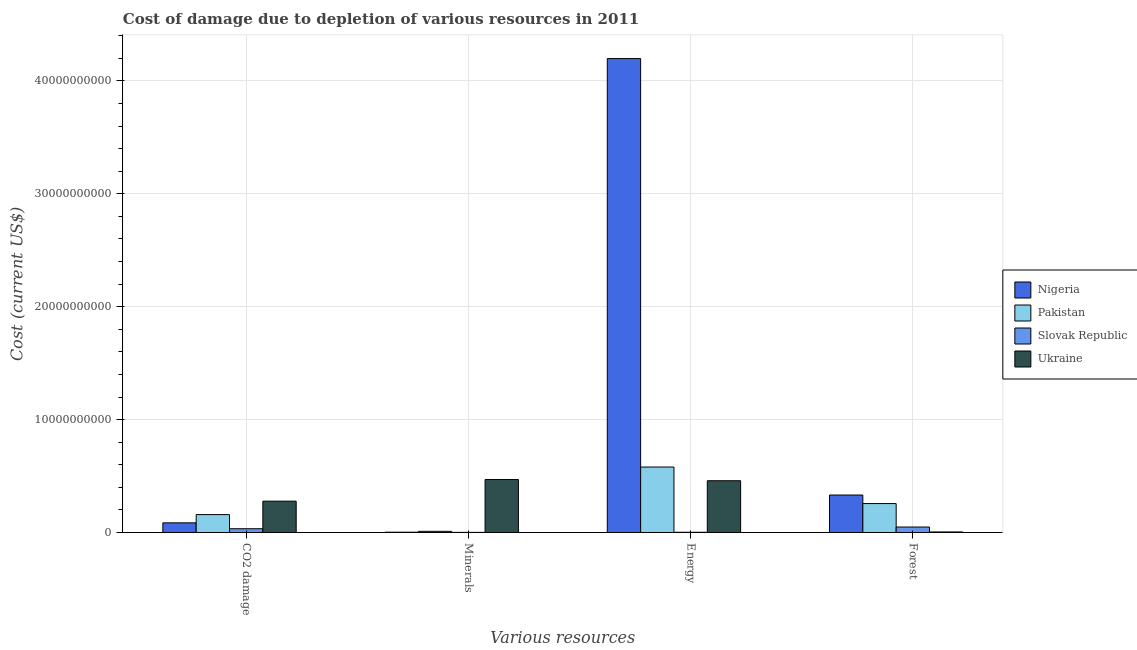How many different coloured bars are there?
Keep it short and to the point. 4. Are the number of bars per tick equal to the number of legend labels?
Make the answer very short. Yes. How many bars are there on the 3rd tick from the left?
Offer a very short reply. 4. How many bars are there on the 1st tick from the right?
Your response must be concise. 4. What is the label of the 4th group of bars from the left?
Your answer should be very brief. Forest. What is the cost of damage due to depletion of energy in Ukraine?
Make the answer very short. 4.58e+09. Across all countries, what is the maximum cost of damage due to depletion of energy?
Offer a terse response. 4.20e+1. Across all countries, what is the minimum cost of damage due to depletion of energy?
Keep it short and to the point. 1.89e+07. In which country was the cost of damage due to depletion of forests maximum?
Provide a short and direct response. Nigeria. In which country was the cost of damage due to depletion of energy minimum?
Provide a succinct answer. Slovak Republic. What is the total cost of damage due to depletion of energy in the graph?
Ensure brevity in your answer.  5.24e+1. What is the difference between the cost of damage due to depletion of forests in Ukraine and that in Slovak Republic?
Make the answer very short. -4.36e+08. What is the difference between the cost of damage due to depletion of coal in Slovak Republic and the cost of damage due to depletion of forests in Ukraine?
Keep it short and to the point. 2.85e+08. What is the average cost of damage due to depletion of minerals per country?
Make the answer very short. 1.21e+09. What is the difference between the cost of damage due to depletion of coal and cost of damage due to depletion of minerals in Ukraine?
Ensure brevity in your answer.  -1.92e+09. In how many countries, is the cost of damage due to depletion of forests greater than 4000000000 US$?
Give a very brief answer. 0. What is the ratio of the cost of damage due to depletion of energy in Ukraine to that in Nigeria?
Keep it short and to the point. 0.11. Is the cost of damage due to depletion of energy in Ukraine less than that in Nigeria?
Your answer should be very brief. Yes. What is the difference between the highest and the second highest cost of damage due to depletion of energy?
Ensure brevity in your answer.  3.62e+1. What is the difference between the highest and the lowest cost of damage due to depletion of minerals?
Offer a very short reply. 4.68e+09. In how many countries, is the cost of damage due to depletion of forests greater than the average cost of damage due to depletion of forests taken over all countries?
Offer a terse response. 2. Is it the case that in every country, the sum of the cost of damage due to depletion of energy and cost of damage due to depletion of coal is greater than the sum of cost of damage due to depletion of forests and cost of damage due to depletion of minerals?
Ensure brevity in your answer.  Yes. What does the 4th bar from the left in Minerals represents?
Your response must be concise. Ukraine. What does the 1st bar from the right in CO2 damage represents?
Make the answer very short. Ukraine. How many bars are there?
Offer a very short reply. 16. Are all the bars in the graph horizontal?
Your response must be concise. No. How many countries are there in the graph?
Provide a succinct answer. 4. What is the difference between two consecutive major ticks on the Y-axis?
Your answer should be compact. 1.00e+1. Does the graph contain grids?
Your response must be concise. Yes. What is the title of the graph?
Your answer should be very brief. Cost of damage due to depletion of various resources in 2011 . What is the label or title of the X-axis?
Keep it short and to the point. Various resources. What is the label or title of the Y-axis?
Ensure brevity in your answer.  Cost (current US$). What is the Cost (current US$) of Nigeria in CO2 damage?
Your answer should be compact. 8.53e+08. What is the Cost (current US$) in Pakistan in CO2 damage?
Make the answer very short. 1.58e+09. What is the Cost (current US$) in Slovak Republic in CO2 damage?
Provide a succinct answer. 3.33e+08. What is the Cost (current US$) of Ukraine in CO2 damage?
Make the answer very short. 2.77e+09. What is the Cost (current US$) in Nigeria in Minerals?
Your answer should be very brief. 2.54e+07. What is the Cost (current US$) of Pakistan in Minerals?
Offer a very short reply. 1.02e+08. What is the Cost (current US$) of Slovak Republic in Minerals?
Your response must be concise. 8.71e+06. What is the Cost (current US$) in Ukraine in Minerals?
Make the answer very short. 4.69e+09. What is the Cost (current US$) in Nigeria in Energy?
Your answer should be very brief. 4.20e+1. What is the Cost (current US$) of Pakistan in Energy?
Give a very brief answer. 5.80e+09. What is the Cost (current US$) of Slovak Republic in Energy?
Provide a succinct answer. 1.89e+07. What is the Cost (current US$) in Ukraine in Energy?
Ensure brevity in your answer.  4.58e+09. What is the Cost (current US$) of Nigeria in Forest?
Offer a terse response. 3.32e+09. What is the Cost (current US$) of Pakistan in Forest?
Offer a very short reply. 2.56e+09. What is the Cost (current US$) in Slovak Republic in Forest?
Your answer should be compact. 4.84e+08. What is the Cost (current US$) in Ukraine in Forest?
Offer a terse response. 4.83e+07. Across all Various resources, what is the maximum Cost (current US$) of Nigeria?
Provide a succinct answer. 4.20e+1. Across all Various resources, what is the maximum Cost (current US$) of Pakistan?
Give a very brief answer. 5.80e+09. Across all Various resources, what is the maximum Cost (current US$) in Slovak Republic?
Make the answer very short. 4.84e+08. Across all Various resources, what is the maximum Cost (current US$) of Ukraine?
Provide a short and direct response. 4.69e+09. Across all Various resources, what is the minimum Cost (current US$) in Nigeria?
Make the answer very short. 2.54e+07. Across all Various resources, what is the minimum Cost (current US$) of Pakistan?
Make the answer very short. 1.02e+08. Across all Various resources, what is the minimum Cost (current US$) of Slovak Republic?
Your answer should be compact. 8.71e+06. Across all Various resources, what is the minimum Cost (current US$) of Ukraine?
Give a very brief answer. 4.83e+07. What is the total Cost (current US$) of Nigeria in the graph?
Your answer should be compact. 4.62e+1. What is the total Cost (current US$) in Pakistan in the graph?
Give a very brief answer. 1.00e+1. What is the total Cost (current US$) of Slovak Republic in the graph?
Make the answer very short. 8.45e+08. What is the total Cost (current US$) of Ukraine in the graph?
Offer a terse response. 1.21e+1. What is the difference between the Cost (current US$) of Nigeria in CO2 damage and that in Minerals?
Provide a succinct answer. 8.28e+08. What is the difference between the Cost (current US$) of Pakistan in CO2 damage and that in Minerals?
Make the answer very short. 1.48e+09. What is the difference between the Cost (current US$) of Slovak Republic in CO2 damage and that in Minerals?
Ensure brevity in your answer.  3.24e+08. What is the difference between the Cost (current US$) in Ukraine in CO2 damage and that in Minerals?
Make the answer very short. -1.92e+09. What is the difference between the Cost (current US$) in Nigeria in CO2 damage and that in Energy?
Provide a short and direct response. -4.11e+1. What is the difference between the Cost (current US$) in Pakistan in CO2 damage and that in Energy?
Offer a terse response. -4.21e+09. What is the difference between the Cost (current US$) in Slovak Republic in CO2 damage and that in Energy?
Provide a succinct answer. 3.14e+08. What is the difference between the Cost (current US$) of Ukraine in CO2 damage and that in Energy?
Make the answer very short. -1.81e+09. What is the difference between the Cost (current US$) in Nigeria in CO2 damage and that in Forest?
Offer a very short reply. -2.47e+09. What is the difference between the Cost (current US$) in Pakistan in CO2 damage and that in Forest?
Give a very brief answer. -9.77e+08. What is the difference between the Cost (current US$) in Slovak Republic in CO2 damage and that in Forest?
Offer a very short reply. -1.51e+08. What is the difference between the Cost (current US$) of Ukraine in CO2 damage and that in Forest?
Give a very brief answer. 2.73e+09. What is the difference between the Cost (current US$) of Nigeria in Minerals and that in Energy?
Keep it short and to the point. -4.20e+1. What is the difference between the Cost (current US$) of Pakistan in Minerals and that in Energy?
Provide a succinct answer. -5.70e+09. What is the difference between the Cost (current US$) of Slovak Republic in Minerals and that in Energy?
Offer a terse response. -1.02e+07. What is the difference between the Cost (current US$) in Ukraine in Minerals and that in Energy?
Keep it short and to the point. 1.05e+08. What is the difference between the Cost (current US$) in Nigeria in Minerals and that in Forest?
Your answer should be compact. -3.29e+09. What is the difference between the Cost (current US$) in Pakistan in Minerals and that in Forest?
Provide a short and direct response. -2.46e+09. What is the difference between the Cost (current US$) of Slovak Republic in Minerals and that in Forest?
Offer a terse response. -4.76e+08. What is the difference between the Cost (current US$) of Ukraine in Minerals and that in Forest?
Keep it short and to the point. 4.64e+09. What is the difference between the Cost (current US$) of Nigeria in Energy and that in Forest?
Offer a terse response. 3.87e+1. What is the difference between the Cost (current US$) in Pakistan in Energy and that in Forest?
Keep it short and to the point. 3.24e+09. What is the difference between the Cost (current US$) of Slovak Republic in Energy and that in Forest?
Offer a terse response. -4.65e+08. What is the difference between the Cost (current US$) of Ukraine in Energy and that in Forest?
Make the answer very short. 4.54e+09. What is the difference between the Cost (current US$) in Nigeria in CO2 damage and the Cost (current US$) in Pakistan in Minerals?
Provide a succinct answer. 7.51e+08. What is the difference between the Cost (current US$) of Nigeria in CO2 damage and the Cost (current US$) of Slovak Republic in Minerals?
Give a very brief answer. 8.45e+08. What is the difference between the Cost (current US$) of Nigeria in CO2 damage and the Cost (current US$) of Ukraine in Minerals?
Give a very brief answer. -3.84e+09. What is the difference between the Cost (current US$) in Pakistan in CO2 damage and the Cost (current US$) in Slovak Republic in Minerals?
Offer a terse response. 1.58e+09. What is the difference between the Cost (current US$) of Pakistan in CO2 damage and the Cost (current US$) of Ukraine in Minerals?
Your response must be concise. -3.11e+09. What is the difference between the Cost (current US$) of Slovak Republic in CO2 damage and the Cost (current US$) of Ukraine in Minerals?
Provide a short and direct response. -4.36e+09. What is the difference between the Cost (current US$) in Nigeria in CO2 damage and the Cost (current US$) in Pakistan in Energy?
Your answer should be compact. -4.94e+09. What is the difference between the Cost (current US$) of Nigeria in CO2 damage and the Cost (current US$) of Slovak Republic in Energy?
Offer a terse response. 8.34e+08. What is the difference between the Cost (current US$) in Nigeria in CO2 damage and the Cost (current US$) in Ukraine in Energy?
Offer a very short reply. -3.73e+09. What is the difference between the Cost (current US$) of Pakistan in CO2 damage and the Cost (current US$) of Slovak Republic in Energy?
Offer a terse response. 1.57e+09. What is the difference between the Cost (current US$) in Pakistan in CO2 damage and the Cost (current US$) in Ukraine in Energy?
Provide a succinct answer. -3.00e+09. What is the difference between the Cost (current US$) of Slovak Republic in CO2 damage and the Cost (current US$) of Ukraine in Energy?
Your answer should be very brief. -4.25e+09. What is the difference between the Cost (current US$) in Nigeria in CO2 damage and the Cost (current US$) in Pakistan in Forest?
Offer a terse response. -1.71e+09. What is the difference between the Cost (current US$) of Nigeria in CO2 damage and the Cost (current US$) of Slovak Republic in Forest?
Make the answer very short. 3.69e+08. What is the difference between the Cost (current US$) in Nigeria in CO2 damage and the Cost (current US$) in Ukraine in Forest?
Ensure brevity in your answer.  8.05e+08. What is the difference between the Cost (current US$) of Pakistan in CO2 damage and the Cost (current US$) of Slovak Republic in Forest?
Keep it short and to the point. 1.10e+09. What is the difference between the Cost (current US$) in Pakistan in CO2 damage and the Cost (current US$) in Ukraine in Forest?
Make the answer very short. 1.54e+09. What is the difference between the Cost (current US$) of Slovak Republic in CO2 damage and the Cost (current US$) of Ukraine in Forest?
Provide a succinct answer. 2.85e+08. What is the difference between the Cost (current US$) in Nigeria in Minerals and the Cost (current US$) in Pakistan in Energy?
Keep it short and to the point. -5.77e+09. What is the difference between the Cost (current US$) of Nigeria in Minerals and the Cost (current US$) of Slovak Republic in Energy?
Keep it short and to the point. 6.54e+06. What is the difference between the Cost (current US$) of Nigeria in Minerals and the Cost (current US$) of Ukraine in Energy?
Give a very brief answer. -4.56e+09. What is the difference between the Cost (current US$) in Pakistan in Minerals and the Cost (current US$) in Slovak Republic in Energy?
Provide a succinct answer. 8.35e+07. What is the difference between the Cost (current US$) of Pakistan in Minerals and the Cost (current US$) of Ukraine in Energy?
Your answer should be very brief. -4.48e+09. What is the difference between the Cost (current US$) in Slovak Republic in Minerals and the Cost (current US$) in Ukraine in Energy?
Offer a terse response. -4.58e+09. What is the difference between the Cost (current US$) in Nigeria in Minerals and the Cost (current US$) in Pakistan in Forest?
Provide a succinct answer. -2.54e+09. What is the difference between the Cost (current US$) in Nigeria in Minerals and the Cost (current US$) in Slovak Republic in Forest?
Your answer should be compact. -4.59e+08. What is the difference between the Cost (current US$) of Nigeria in Minerals and the Cost (current US$) of Ukraine in Forest?
Your answer should be very brief. -2.28e+07. What is the difference between the Cost (current US$) in Pakistan in Minerals and the Cost (current US$) in Slovak Republic in Forest?
Ensure brevity in your answer.  -3.82e+08. What is the difference between the Cost (current US$) in Pakistan in Minerals and the Cost (current US$) in Ukraine in Forest?
Provide a short and direct response. 5.41e+07. What is the difference between the Cost (current US$) of Slovak Republic in Minerals and the Cost (current US$) of Ukraine in Forest?
Offer a very short reply. -3.96e+07. What is the difference between the Cost (current US$) in Nigeria in Energy and the Cost (current US$) in Pakistan in Forest?
Make the answer very short. 3.94e+1. What is the difference between the Cost (current US$) of Nigeria in Energy and the Cost (current US$) of Slovak Republic in Forest?
Keep it short and to the point. 4.15e+1. What is the difference between the Cost (current US$) of Nigeria in Energy and the Cost (current US$) of Ukraine in Forest?
Make the answer very short. 4.19e+1. What is the difference between the Cost (current US$) of Pakistan in Energy and the Cost (current US$) of Slovak Republic in Forest?
Give a very brief answer. 5.31e+09. What is the difference between the Cost (current US$) in Pakistan in Energy and the Cost (current US$) in Ukraine in Forest?
Your answer should be very brief. 5.75e+09. What is the difference between the Cost (current US$) in Slovak Republic in Energy and the Cost (current US$) in Ukraine in Forest?
Ensure brevity in your answer.  -2.94e+07. What is the average Cost (current US$) of Nigeria per Various resources?
Offer a very short reply. 1.15e+1. What is the average Cost (current US$) of Pakistan per Various resources?
Give a very brief answer. 2.51e+09. What is the average Cost (current US$) of Slovak Republic per Various resources?
Offer a terse response. 2.11e+08. What is the average Cost (current US$) of Ukraine per Various resources?
Offer a very short reply. 3.02e+09. What is the difference between the Cost (current US$) of Nigeria and Cost (current US$) of Pakistan in CO2 damage?
Offer a very short reply. -7.31e+08. What is the difference between the Cost (current US$) of Nigeria and Cost (current US$) of Slovak Republic in CO2 damage?
Offer a very short reply. 5.20e+08. What is the difference between the Cost (current US$) in Nigeria and Cost (current US$) in Ukraine in CO2 damage?
Provide a short and direct response. -1.92e+09. What is the difference between the Cost (current US$) in Pakistan and Cost (current US$) in Slovak Republic in CO2 damage?
Give a very brief answer. 1.25e+09. What is the difference between the Cost (current US$) in Pakistan and Cost (current US$) in Ukraine in CO2 damage?
Your response must be concise. -1.19e+09. What is the difference between the Cost (current US$) of Slovak Republic and Cost (current US$) of Ukraine in CO2 damage?
Your answer should be very brief. -2.44e+09. What is the difference between the Cost (current US$) of Nigeria and Cost (current US$) of Pakistan in Minerals?
Your answer should be compact. -7.70e+07. What is the difference between the Cost (current US$) of Nigeria and Cost (current US$) of Slovak Republic in Minerals?
Provide a succinct answer. 1.67e+07. What is the difference between the Cost (current US$) of Nigeria and Cost (current US$) of Ukraine in Minerals?
Give a very brief answer. -4.66e+09. What is the difference between the Cost (current US$) of Pakistan and Cost (current US$) of Slovak Republic in Minerals?
Give a very brief answer. 9.37e+07. What is the difference between the Cost (current US$) in Pakistan and Cost (current US$) in Ukraine in Minerals?
Offer a very short reply. -4.59e+09. What is the difference between the Cost (current US$) of Slovak Republic and Cost (current US$) of Ukraine in Minerals?
Your answer should be compact. -4.68e+09. What is the difference between the Cost (current US$) of Nigeria and Cost (current US$) of Pakistan in Energy?
Offer a terse response. 3.62e+1. What is the difference between the Cost (current US$) in Nigeria and Cost (current US$) in Slovak Republic in Energy?
Your response must be concise. 4.20e+1. What is the difference between the Cost (current US$) of Nigeria and Cost (current US$) of Ukraine in Energy?
Offer a terse response. 3.74e+1. What is the difference between the Cost (current US$) in Pakistan and Cost (current US$) in Slovak Republic in Energy?
Ensure brevity in your answer.  5.78e+09. What is the difference between the Cost (current US$) in Pakistan and Cost (current US$) in Ukraine in Energy?
Ensure brevity in your answer.  1.21e+09. What is the difference between the Cost (current US$) of Slovak Republic and Cost (current US$) of Ukraine in Energy?
Ensure brevity in your answer.  -4.57e+09. What is the difference between the Cost (current US$) of Nigeria and Cost (current US$) of Pakistan in Forest?
Ensure brevity in your answer.  7.57e+08. What is the difference between the Cost (current US$) of Nigeria and Cost (current US$) of Slovak Republic in Forest?
Your answer should be compact. 2.83e+09. What is the difference between the Cost (current US$) in Nigeria and Cost (current US$) in Ukraine in Forest?
Your answer should be compact. 3.27e+09. What is the difference between the Cost (current US$) in Pakistan and Cost (current US$) in Slovak Republic in Forest?
Your answer should be compact. 2.08e+09. What is the difference between the Cost (current US$) in Pakistan and Cost (current US$) in Ukraine in Forest?
Make the answer very short. 2.51e+09. What is the difference between the Cost (current US$) in Slovak Republic and Cost (current US$) in Ukraine in Forest?
Offer a terse response. 4.36e+08. What is the ratio of the Cost (current US$) of Nigeria in CO2 damage to that in Minerals?
Make the answer very short. 33.55. What is the ratio of the Cost (current US$) in Pakistan in CO2 damage to that in Minerals?
Provide a short and direct response. 15.47. What is the ratio of the Cost (current US$) of Slovak Republic in CO2 damage to that in Minerals?
Provide a succinct answer. 38.27. What is the ratio of the Cost (current US$) of Ukraine in CO2 damage to that in Minerals?
Give a very brief answer. 0.59. What is the ratio of the Cost (current US$) of Nigeria in CO2 damage to that in Energy?
Make the answer very short. 0.02. What is the ratio of the Cost (current US$) of Pakistan in CO2 damage to that in Energy?
Keep it short and to the point. 0.27. What is the ratio of the Cost (current US$) of Slovak Republic in CO2 damage to that in Energy?
Provide a short and direct response. 17.64. What is the ratio of the Cost (current US$) in Ukraine in CO2 damage to that in Energy?
Offer a very short reply. 0.61. What is the ratio of the Cost (current US$) in Nigeria in CO2 damage to that in Forest?
Ensure brevity in your answer.  0.26. What is the ratio of the Cost (current US$) of Pakistan in CO2 damage to that in Forest?
Give a very brief answer. 0.62. What is the ratio of the Cost (current US$) of Slovak Republic in CO2 damage to that in Forest?
Keep it short and to the point. 0.69. What is the ratio of the Cost (current US$) of Ukraine in CO2 damage to that in Forest?
Provide a succinct answer. 57.47. What is the ratio of the Cost (current US$) of Nigeria in Minerals to that in Energy?
Keep it short and to the point. 0. What is the ratio of the Cost (current US$) in Pakistan in Minerals to that in Energy?
Provide a short and direct response. 0.02. What is the ratio of the Cost (current US$) of Slovak Republic in Minerals to that in Energy?
Ensure brevity in your answer.  0.46. What is the ratio of the Cost (current US$) of Nigeria in Minerals to that in Forest?
Make the answer very short. 0.01. What is the ratio of the Cost (current US$) in Pakistan in Minerals to that in Forest?
Keep it short and to the point. 0.04. What is the ratio of the Cost (current US$) of Slovak Republic in Minerals to that in Forest?
Keep it short and to the point. 0.02. What is the ratio of the Cost (current US$) in Ukraine in Minerals to that in Forest?
Your answer should be very brief. 97.15. What is the ratio of the Cost (current US$) of Nigeria in Energy to that in Forest?
Offer a very short reply. 12.65. What is the ratio of the Cost (current US$) of Pakistan in Energy to that in Forest?
Your response must be concise. 2.26. What is the ratio of the Cost (current US$) in Slovak Republic in Energy to that in Forest?
Give a very brief answer. 0.04. What is the ratio of the Cost (current US$) of Ukraine in Energy to that in Forest?
Make the answer very short. 94.97. What is the difference between the highest and the second highest Cost (current US$) of Nigeria?
Your answer should be compact. 3.87e+1. What is the difference between the highest and the second highest Cost (current US$) of Pakistan?
Keep it short and to the point. 3.24e+09. What is the difference between the highest and the second highest Cost (current US$) of Slovak Republic?
Provide a succinct answer. 1.51e+08. What is the difference between the highest and the second highest Cost (current US$) in Ukraine?
Your answer should be very brief. 1.05e+08. What is the difference between the highest and the lowest Cost (current US$) in Nigeria?
Your answer should be compact. 4.20e+1. What is the difference between the highest and the lowest Cost (current US$) in Pakistan?
Your response must be concise. 5.70e+09. What is the difference between the highest and the lowest Cost (current US$) in Slovak Republic?
Keep it short and to the point. 4.76e+08. What is the difference between the highest and the lowest Cost (current US$) in Ukraine?
Your answer should be compact. 4.64e+09. 